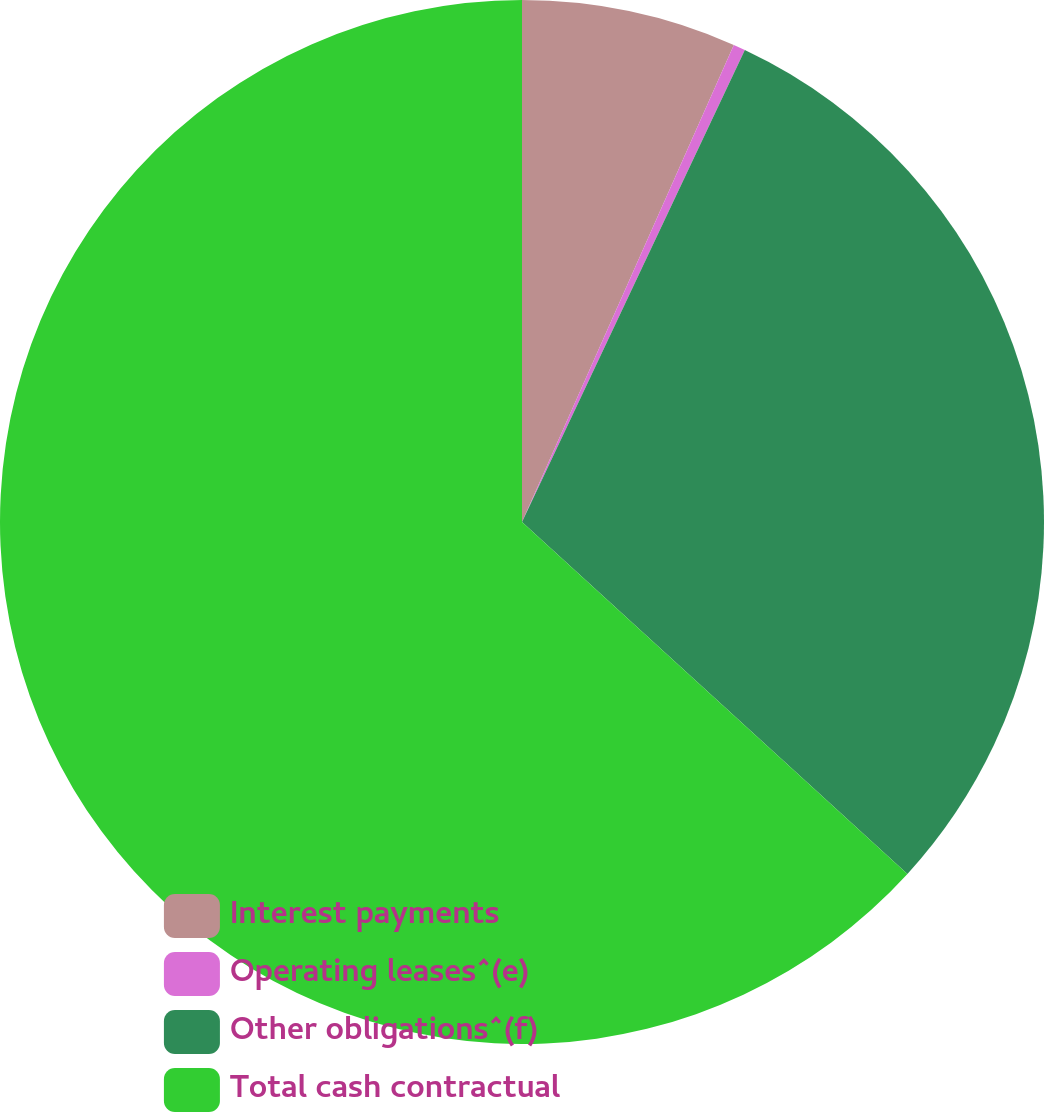<chart> <loc_0><loc_0><loc_500><loc_500><pie_chart><fcel>Interest payments<fcel>Operating leases^(e)<fcel>Other obligations^(f)<fcel>Total cash contractual<nl><fcel>6.65%<fcel>0.37%<fcel>29.76%<fcel>63.22%<nl></chart> 